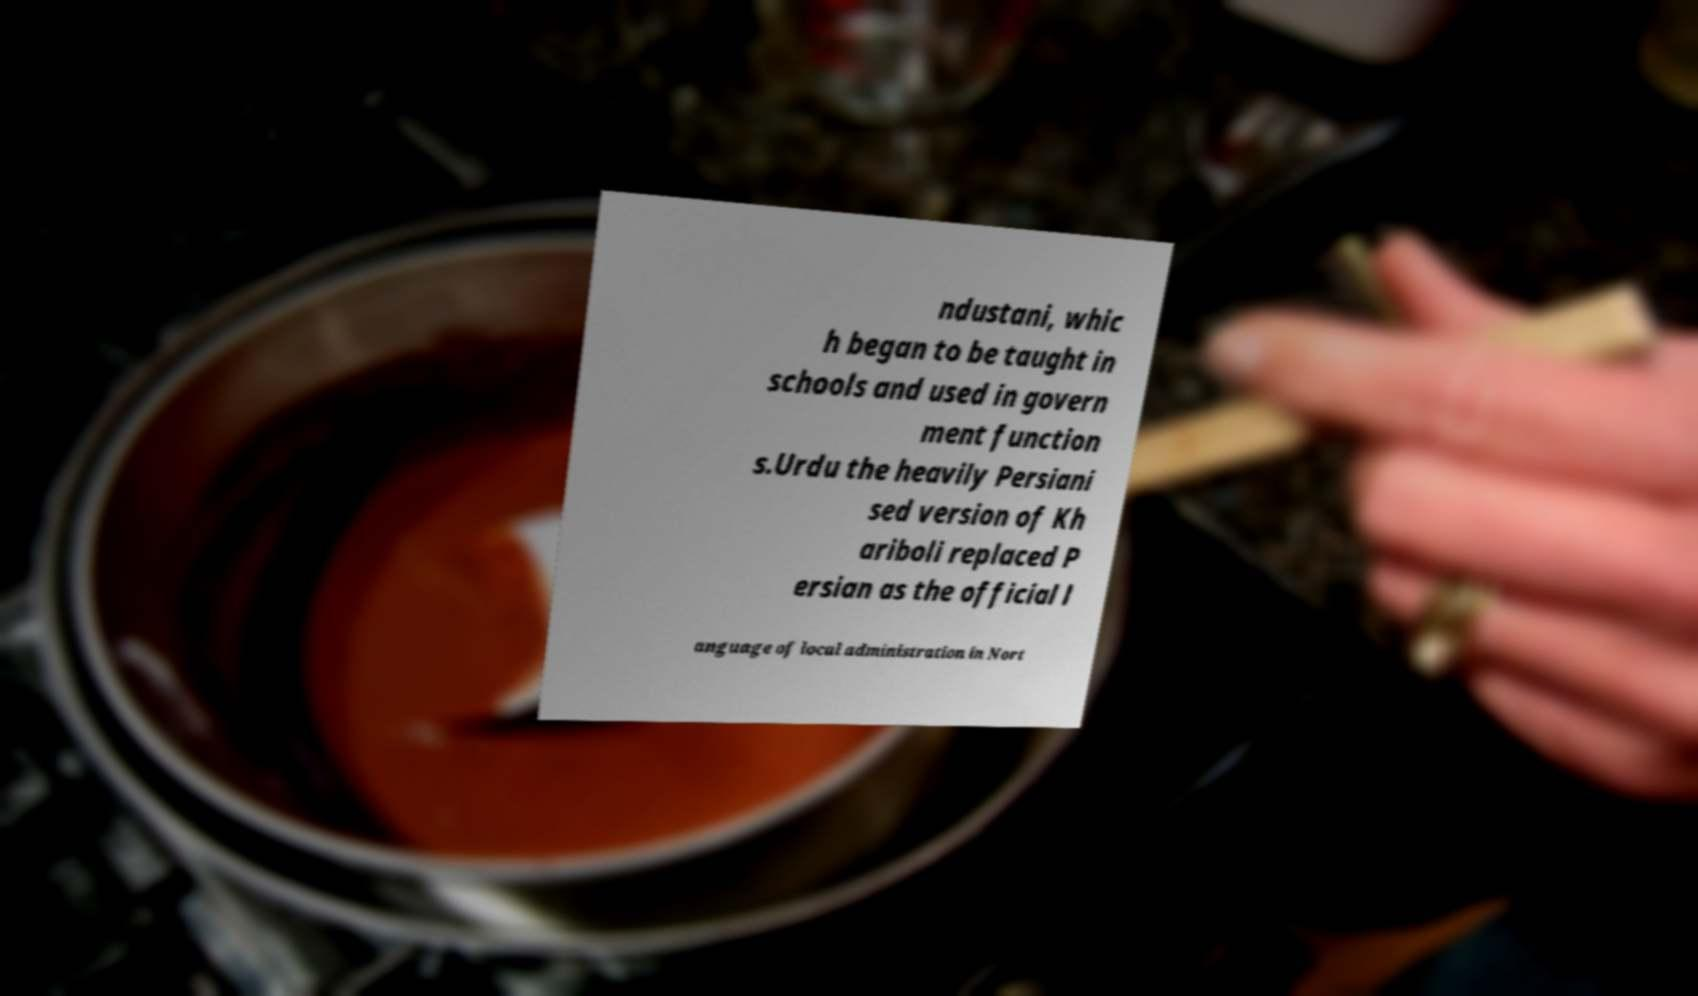Please read and relay the text visible in this image. What does it say? ndustani, whic h began to be taught in schools and used in govern ment function s.Urdu the heavily Persiani sed version of Kh ariboli replaced P ersian as the official l anguage of local administration in Nort 